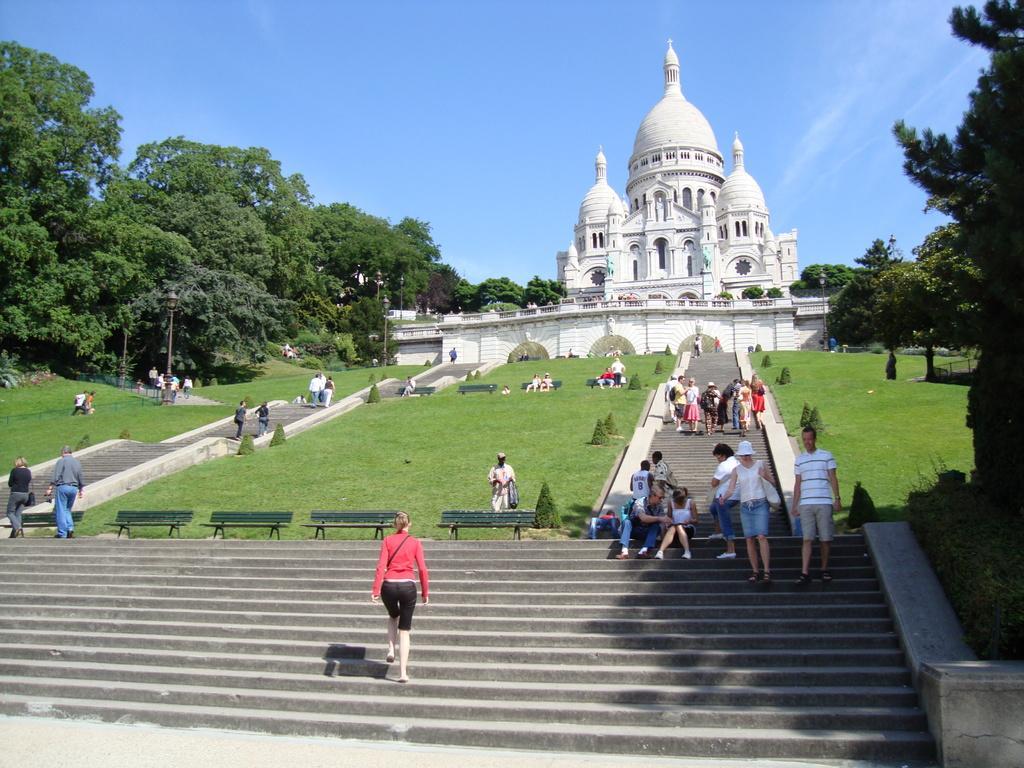Could you give a brief overview of what you see in this image? Here we can see group of people. This is grass. There are benches, plants, poles, lights, trees, and ancient architecture. In the background there is sky. 